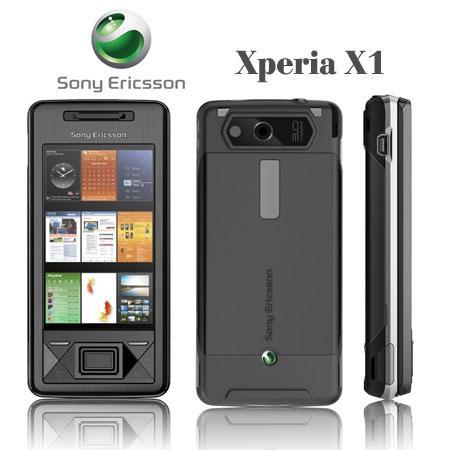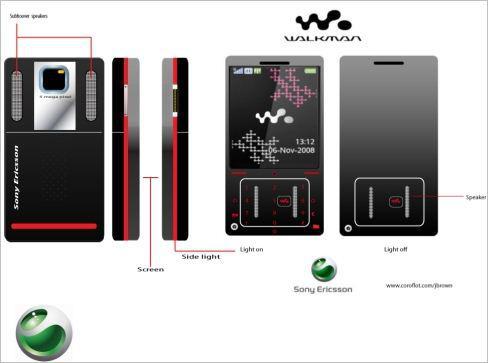The first image is the image on the left, the second image is the image on the right. Evaluate the accuracy of this statement regarding the images: "Each image in the pair shows multiple views of a mobile device.". Is it true? Answer yes or no. Yes. 